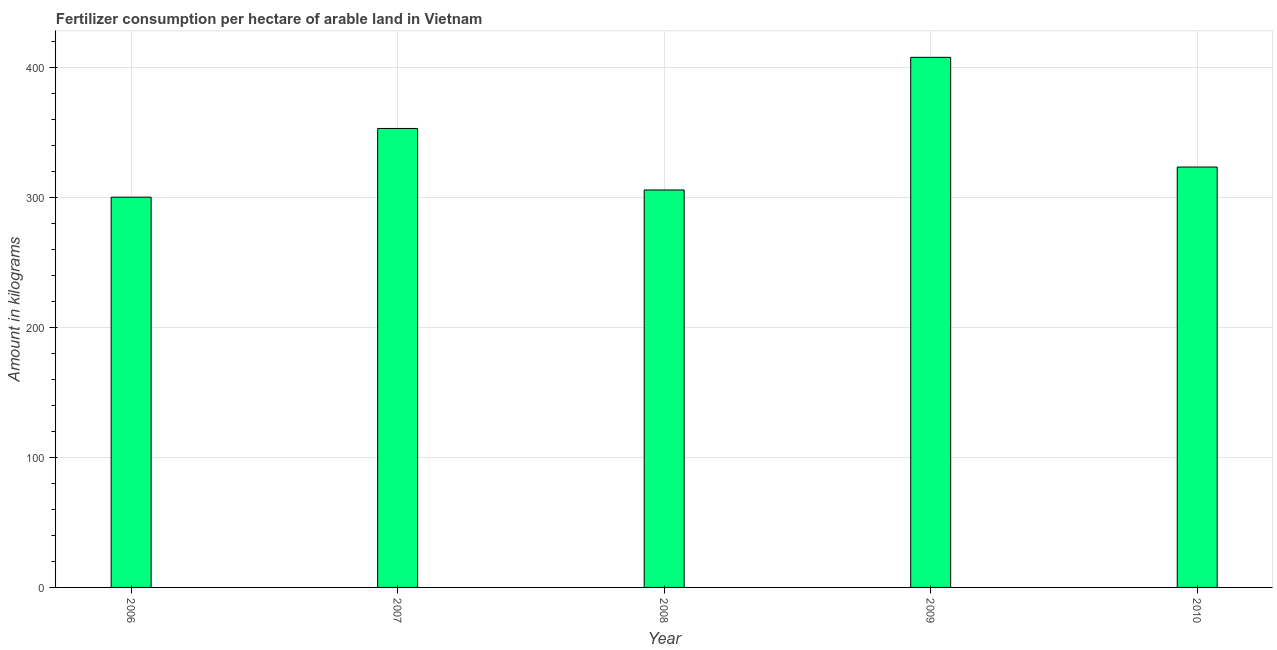Does the graph contain any zero values?
Your response must be concise. No. Does the graph contain grids?
Keep it short and to the point. Yes. What is the title of the graph?
Your answer should be very brief. Fertilizer consumption per hectare of arable land in Vietnam . What is the label or title of the X-axis?
Give a very brief answer. Year. What is the label or title of the Y-axis?
Your response must be concise. Amount in kilograms. What is the amount of fertilizer consumption in 2009?
Your response must be concise. 407.72. Across all years, what is the maximum amount of fertilizer consumption?
Give a very brief answer. 407.72. Across all years, what is the minimum amount of fertilizer consumption?
Make the answer very short. 300.17. In which year was the amount of fertilizer consumption maximum?
Your response must be concise. 2009. In which year was the amount of fertilizer consumption minimum?
Your answer should be compact. 2006. What is the sum of the amount of fertilizer consumption?
Provide a short and direct response. 1689.93. What is the difference between the amount of fertilizer consumption in 2006 and 2007?
Your answer should be compact. -52.84. What is the average amount of fertilizer consumption per year?
Your answer should be compact. 337.99. What is the median amount of fertilizer consumption?
Your answer should be very brief. 323.34. Do a majority of the years between 2006 and 2007 (inclusive) have amount of fertilizer consumption greater than 140 kg?
Your answer should be compact. Yes. What is the ratio of the amount of fertilizer consumption in 2007 to that in 2010?
Provide a short and direct response. 1.09. What is the difference between the highest and the second highest amount of fertilizer consumption?
Your response must be concise. 54.71. Is the sum of the amount of fertilizer consumption in 2006 and 2009 greater than the maximum amount of fertilizer consumption across all years?
Ensure brevity in your answer.  Yes. What is the difference between the highest and the lowest amount of fertilizer consumption?
Offer a terse response. 107.55. In how many years, is the amount of fertilizer consumption greater than the average amount of fertilizer consumption taken over all years?
Your answer should be very brief. 2. How many bars are there?
Provide a succinct answer. 5. What is the Amount in kilograms of 2006?
Ensure brevity in your answer.  300.17. What is the Amount in kilograms of 2007?
Provide a short and direct response. 353.01. What is the Amount in kilograms of 2008?
Your answer should be very brief. 305.7. What is the Amount in kilograms in 2009?
Provide a succinct answer. 407.72. What is the Amount in kilograms in 2010?
Provide a succinct answer. 323.34. What is the difference between the Amount in kilograms in 2006 and 2007?
Provide a succinct answer. -52.84. What is the difference between the Amount in kilograms in 2006 and 2008?
Make the answer very short. -5.53. What is the difference between the Amount in kilograms in 2006 and 2009?
Give a very brief answer. -107.55. What is the difference between the Amount in kilograms in 2006 and 2010?
Give a very brief answer. -23.17. What is the difference between the Amount in kilograms in 2007 and 2008?
Provide a short and direct response. 47.31. What is the difference between the Amount in kilograms in 2007 and 2009?
Give a very brief answer. -54.71. What is the difference between the Amount in kilograms in 2007 and 2010?
Your response must be concise. 29.67. What is the difference between the Amount in kilograms in 2008 and 2009?
Provide a succinct answer. -102.02. What is the difference between the Amount in kilograms in 2008 and 2010?
Offer a very short reply. -17.64. What is the difference between the Amount in kilograms in 2009 and 2010?
Your response must be concise. 84.38. What is the ratio of the Amount in kilograms in 2006 to that in 2009?
Provide a succinct answer. 0.74. What is the ratio of the Amount in kilograms in 2006 to that in 2010?
Give a very brief answer. 0.93. What is the ratio of the Amount in kilograms in 2007 to that in 2008?
Your answer should be very brief. 1.16. What is the ratio of the Amount in kilograms in 2007 to that in 2009?
Provide a short and direct response. 0.87. What is the ratio of the Amount in kilograms in 2007 to that in 2010?
Give a very brief answer. 1.09. What is the ratio of the Amount in kilograms in 2008 to that in 2010?
Provide a short and direct response. 0.94. What is the ratio of the Amount in kilograms in 2009 to that in 2010?
Offer a terse response. 1.26. 